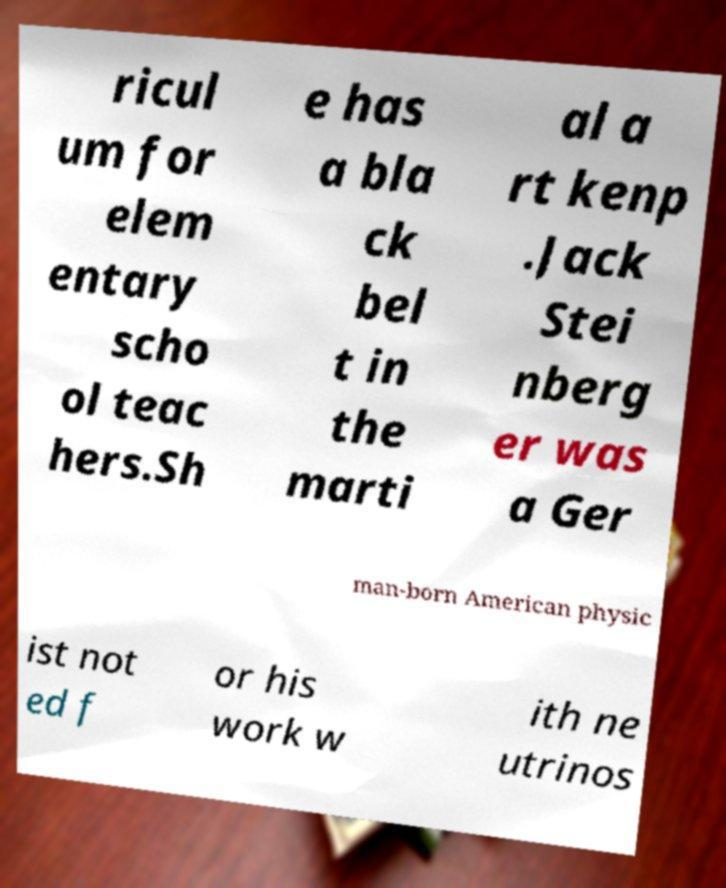Can you read and provide the text displayed in the image?This photo seems to have some interesting text. Can you extract and type it out for me? ricul um for elem entary scho ol teac hers.Sh e has a bla ck bel t in the marti al a rt kenp .Jack Stei nberg er was a Ger man-born American physic ist not ed f or his work w ith ne utrinos 